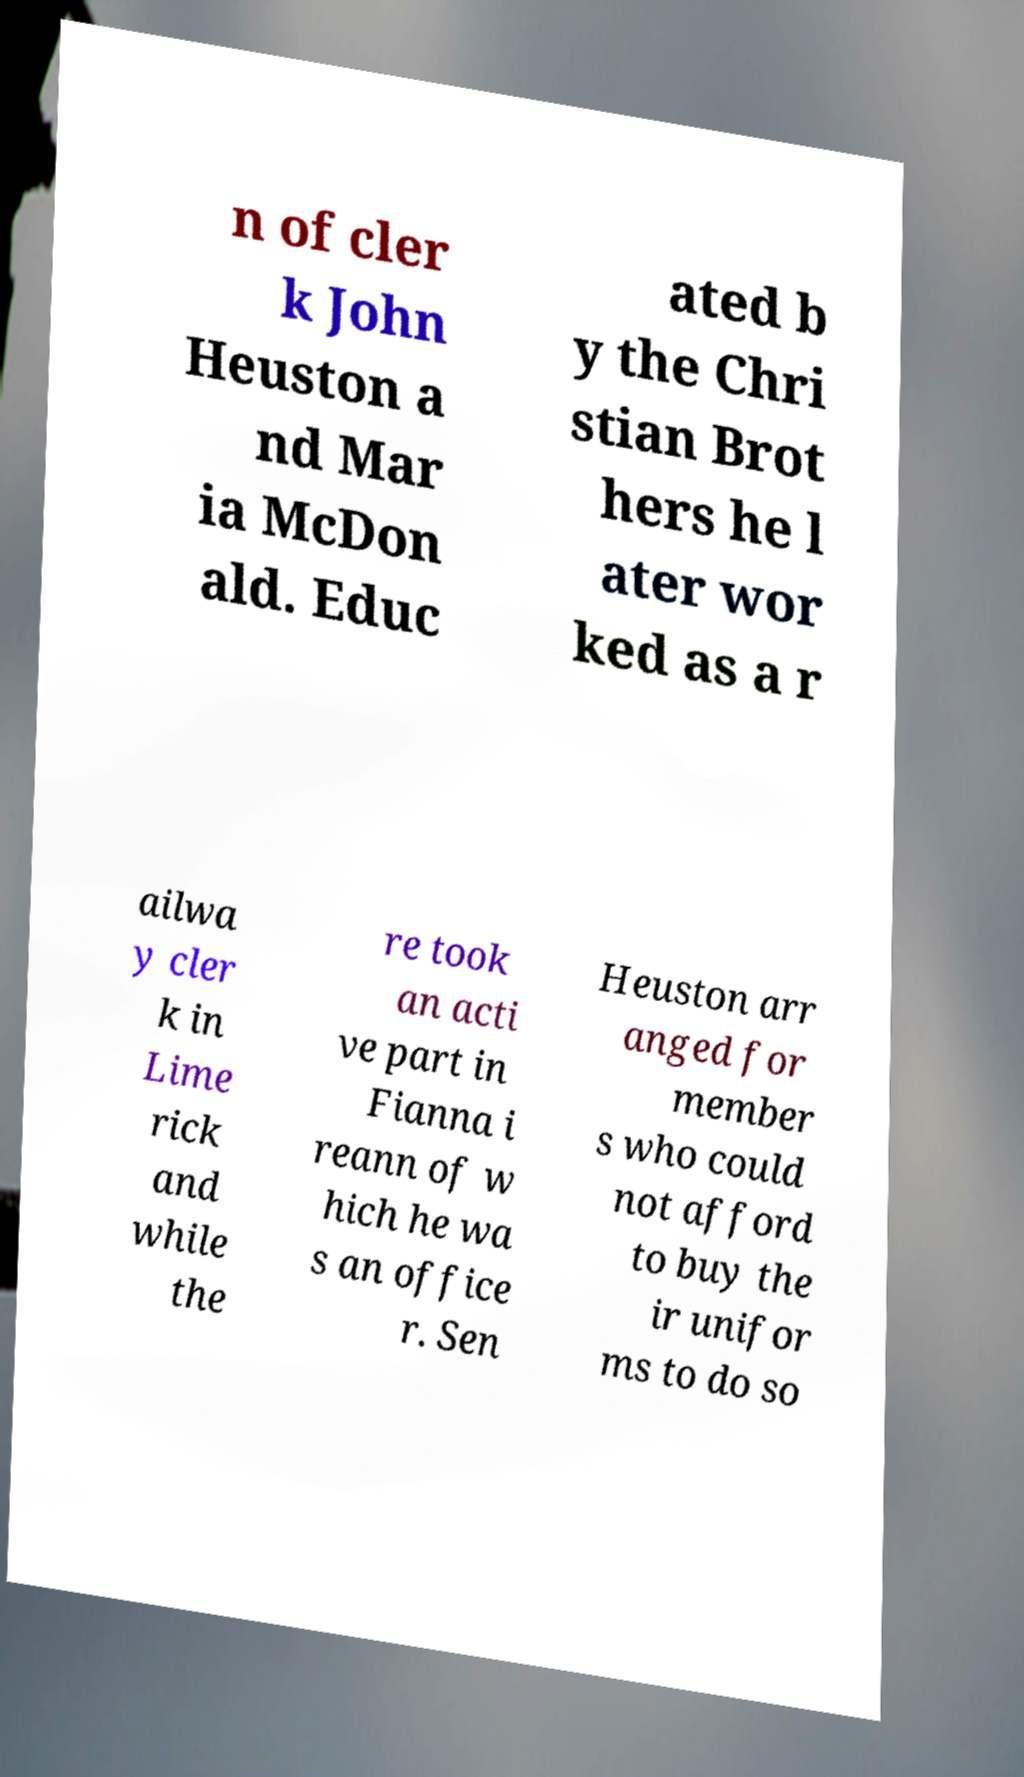Please identify and transcribe the text found in this image. n of cler k John Heuston a nd Mar ia McDon ald. Educ ated b y the Chri stian Brot hers he l ater wor ked as a r ailwa y cler k in Lime rick and while the re took an acti ve part in Fianna i reann of w hich he wa s an office r. Sen Heuston arr anged for member s who could not afford to buy the ir unifor ms to do so 